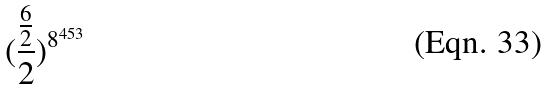Convert formula to latex. <formula><loc_0><loc_0><loc_500><loc_500>( \frac { \frac { 6 } { 2 } } { 2 } ) ^ { 8 ^ { 4 5 3 } }</formula> 